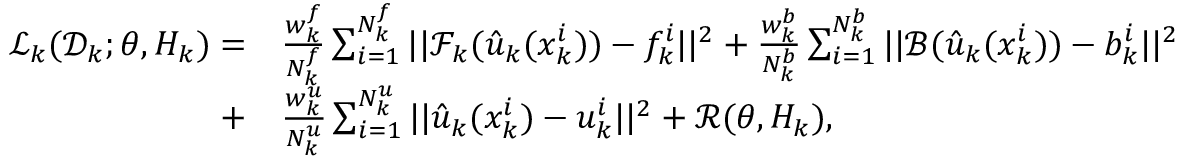<formula> <loc_0><loc_0><loc_500><loc_500>\begin{array} { r l } { \mathcal { L } _ { k } ( \mathcal { D } _ { k } ; \theta , H _ { k } ) = } & \frac { w _ { k } ^ { f } } { N _ { k } ^ { f } } \sum _ { i = 1 } ^ { N _ { k } ^ { f } } | | \mathcal { F } _ { k } ( \hat { u } _ { k } ( x _ { k } ^ { i } ) ) - f _ { k } ^ { i } | | ^ { 2 } + \frac { w _ { k } ^ { b } } { N _ { k } ^ { b } } \sum _ { i = 1 } ^ { N _ { k } ^ { b } } | | \mathcal { B } ( \hat { u } _ { k } ( x _ { k } ^ { i } ) ) - b _ { k } ^ { i } | | ^ { 2 } } \\ { + } & \frac { w _ { k } ^ { u } } { N _ { k } ^ { u } } \sum _ { i = 1 } ^ { N _ { k } ^ { u } } | | \hat { u } _ { k } ( x _ { k } ^ { i } ) - u _ { k } ^ { i } | | ^ { 2 } + \mathcal { R } ( \theta , H _ { k } ) , } \end{array}</formula> 